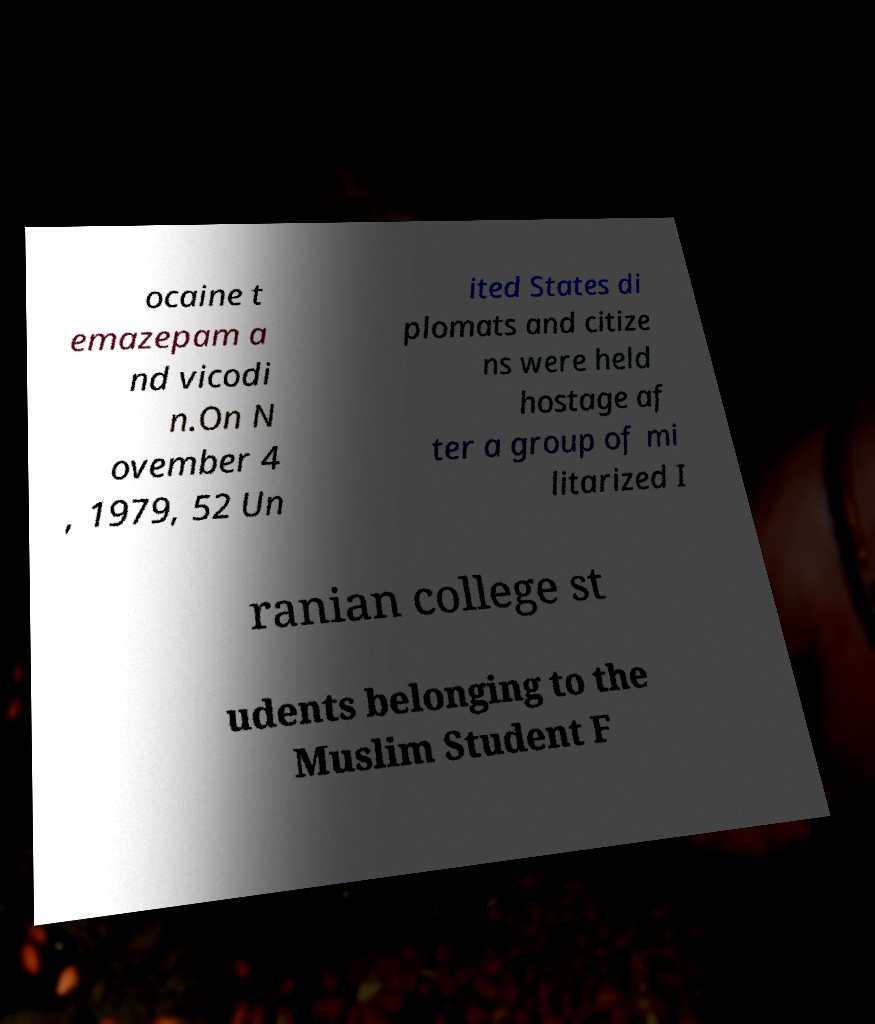Can you read and provide the text displayed in the image?This photo seems to have some interesting text. Can you extract and type it out for me? ocaine t emazepam a nd vicodi n.On N ovember 4 , 1979, 52 Un ited States di plomats and citize ns were held hostage af ter a group of mi litarized I ranian college st udents belonging to the Muslim Student F 